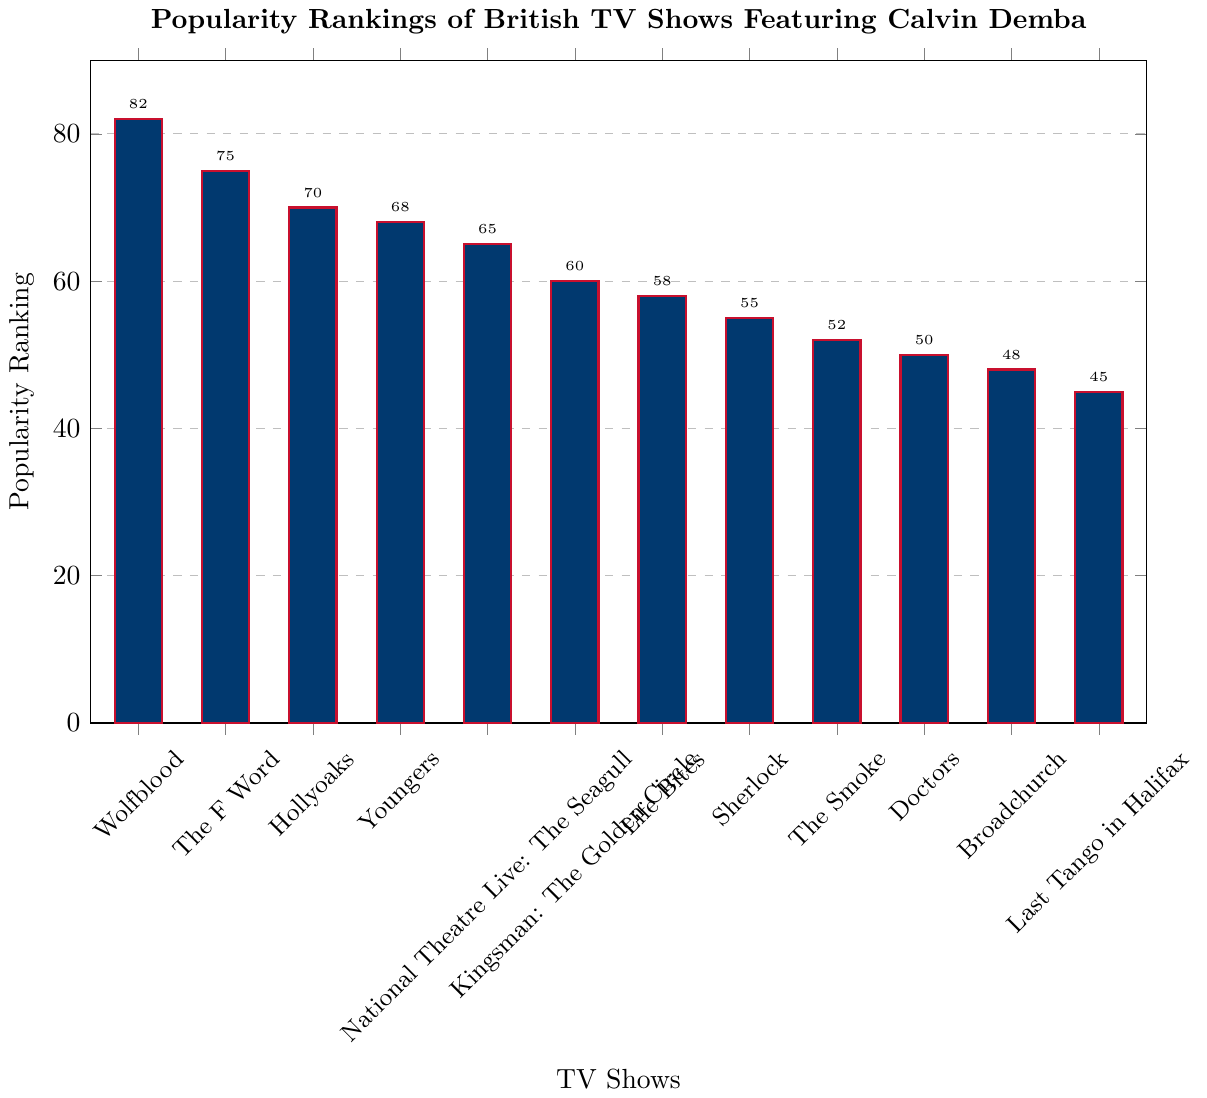What's the most popular TV show featuring Calvin Demba? The bar chart shows the popularity rankings of various TV shows. By identifying the highest bar, which represents the highest ranking, we can see that "Wolfblood" has the highest value at 82.
Answer: Wolfblood Which show has a lower ranking, "Sherlock" or "Doctors"? By comparing the heights and corresponding values of the bars for "Sherlock" and "Doctors", we see that "Sherlock" is at 55 and "Doctors" is at 50. Since 50 is lower than 55, "Doctors" has a lower ranking.
Answer: Doctors What is the range of the popularity rankings of the shows? The range is calculated by subtracting the smallest value from the largest value. The highest ranking is 82 ("Wolfblood") and the lowest ranking is 45 ("Last Tango in Halifax"), so the range is 82 - 45 = 37.
Answer: 37 What is the sum of the popularity rankings of "Wolfblood", "The F Word", and "Hollyoaks"? To find the sum, add the popularity rankings of "Wolfblood" (82), "The F Word" (75), and "Hollyoaks" (70). So, 82 + 75 + 70 = 227.
Answer: 227 How many shows have a popularity ranking greater than 60? Identify the bars with values greater than 60. They are "Wolfblood" (82), "The F Word" (75), "Hollyoaks" (70), "Youngers" (68), and "National Theatre Live: The Seagull" (65). Counting these, there are 5 shows.
Answer: 5 What is the average popularity ranking of the shows? Sum all the popularity rankings and then divide by the number of shows. The sum is (82 + 75 + 70 + 68 + 65 + 60 + 58 + 55 + 52 + 50 + 48 + 45) = 728. There are 12 shows, so the average is 728 / 12 = 60.67.
Answer: 60.67 Which show is ranked exactly in the middle when the rankings are sorted in ascending order? Arrange the values in ascending order (45, 48, 50, 52, 55, 58, 60, 65, 68, 70, 75, 82). The 6th and 7th values (middle ones) are 58 and 60. The average of these two is 59. Since "Life Bites" is ranked 58, it is close to the median position.
Answer: Life Bites Does "Kingsman: The Golden Circle" have a higher or lower ranking compared to the average ranking of the shows? The average ranking we calculated is 60.67. "Kingsman: The Golden Circle" has a ranking of 60, which is lower than the average.
Answer: Lower 